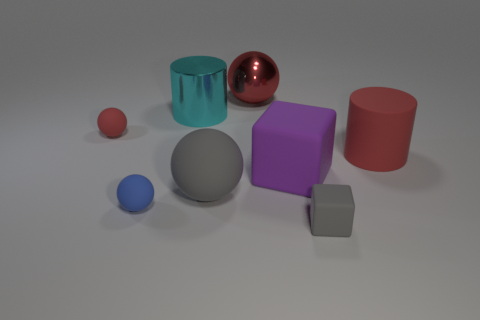Are the large purple object and the large gray sphere made of the same material?
Your answer should be compact. Yes. How many blocks are red rubber things or small blue rubber objects?
Make the answer very short. 0. The big cylinder that is on the right side of the large cylinder that is to the left of the big red metallic sphere is what color?
Provide a short and direct response. Red. There is a thing that is the same color as the large matte ball; what is its size?
Offer a terse response. Small. There is a big red object in front of the big shiny object that is to the left of the large rubber ball; what number of small blue balls are behind it?
Your response must be concise. 0. Is the shape of the red matte object that is on the left side of the red cylinder the same as the large red object in front of the red metal sphere?
Give a very brief answer. No. What number of things are either large cyan shiny things or small blue metal cylinders?
Your answer should be very brief. 1. The small ball that is in front of the red sphere left of the cyan shiny cylinder is made of what material?
Ensure brevity in your answer.  Rubber. Is there a big matte thing of the same color as the large cube?
Provide a short and direct response. No. There is another matte cylinder that is the same size as the cyan cylinder; what is its color?
Your response must be concise. Red. 